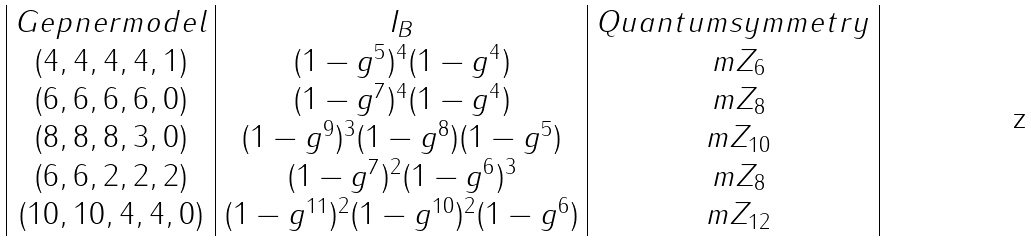<formula> <loc_0><loc_0><loc_500><loc_500>\begin{array} { | c | c | c | } G e p n e r m o d e l & I _ { B } & Q u a n t u m s y m m e t r y \\ ( 4 , 4 , 4 , 4 , 1 ) & ( 1 - g ^ { 5 } ) ^ { 4 } ( 1 - g ^ { 4 } ) & \ m Z _ { 6 } \\ ( 6 , 6 , 6 , 6 , 0 ) & ( 1 - g ^ { 7 } ) ^ { 4 } ( 1 - g ^ { 4 } ) & \ m Z _ { 8 } \\ ( 8 , 8 , 8 , 3 , 0 ) & ( 1 - g ^ { 9 } ) ^ { 3 } ( 1 - g ^ { 8 } ) ( 1 - g ^ { 5 } ) & \ m Z _ { 1 0 } \\ ( 6 , 6 , 2 , 2 , 2 ) & ( 1 - g ^ { 7 } ) ^ { 2 } ( 1 - g ^ { 6 } ) ^ { 3 } & \ m Z _ { 8 } \\ ( 1 0 , 1 0 , 4 , 4 , 0 ) & ( 1 - g ^ { 1 1 } ) ^ { 2 } ( 1 - g ^ { 1 0 } ) ^ { 2 } ( 1 - g ^ { 6 } ) & \ m Z _ { 1 2 } \\ \end{array}</formula> 